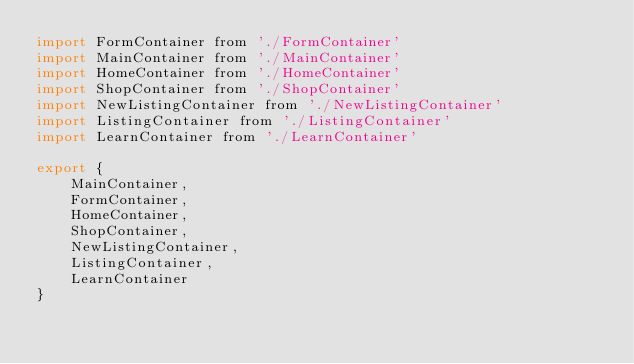<code> <loc_0><loc_0><loc_500><loc_500><_JavaScript_>import FormContainer from './FormContainer'
import MainContainer from './MainContainer'
import HomeContainer from './HomeContainer'
import ShopContainer from './ShopContainer'
import NewListingContainer from './NewListingContainer'
import ListingContainer from './ListingContainer'
import LearnContainer from './LearnContainer'

export {
    MainContainer,
    FormContainer,
    HomeContainer,
    ShopContainer,
    NewListingContainer,
    ListingContainer,
    LearnContainer
}
</code> 